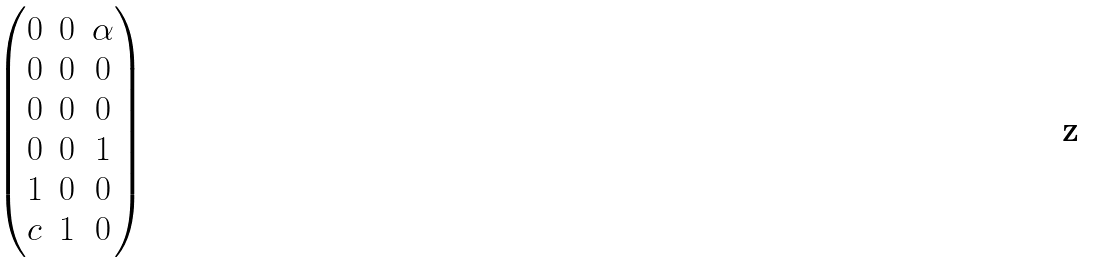Convert formula to latex. <formula><loc_0><loc_0><loc_500><loc_500>\begin{pmatrix} 0 & 0 & \alpha \\ 0 & 0 & 0 \\ 0 & 0 & 0 \\ 0 & 0 & 1 \\ 1 & 0 & 0 \\ c & 1 & 0 \end{pmatrix}</formula> 